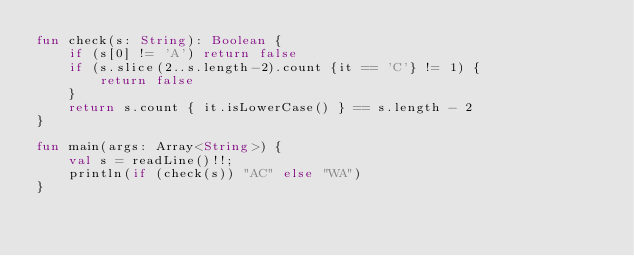<code> <loc_0><loc_0><loc_500><loc_500><_Kotlin_>fun check(s: String): Boolean {
    if (s[0] != 'A') return false
    if (s.slice(2..s.length-2).count {it == 'C'} != 1) {
        return false
    }
    return s.count { it.isLowerCase() } == s.length - 2
}

fun main(args: Array<String>) {
    val s = readLine()!!;
    println(if (check(s)) "AC" else "WA")
}</code> 